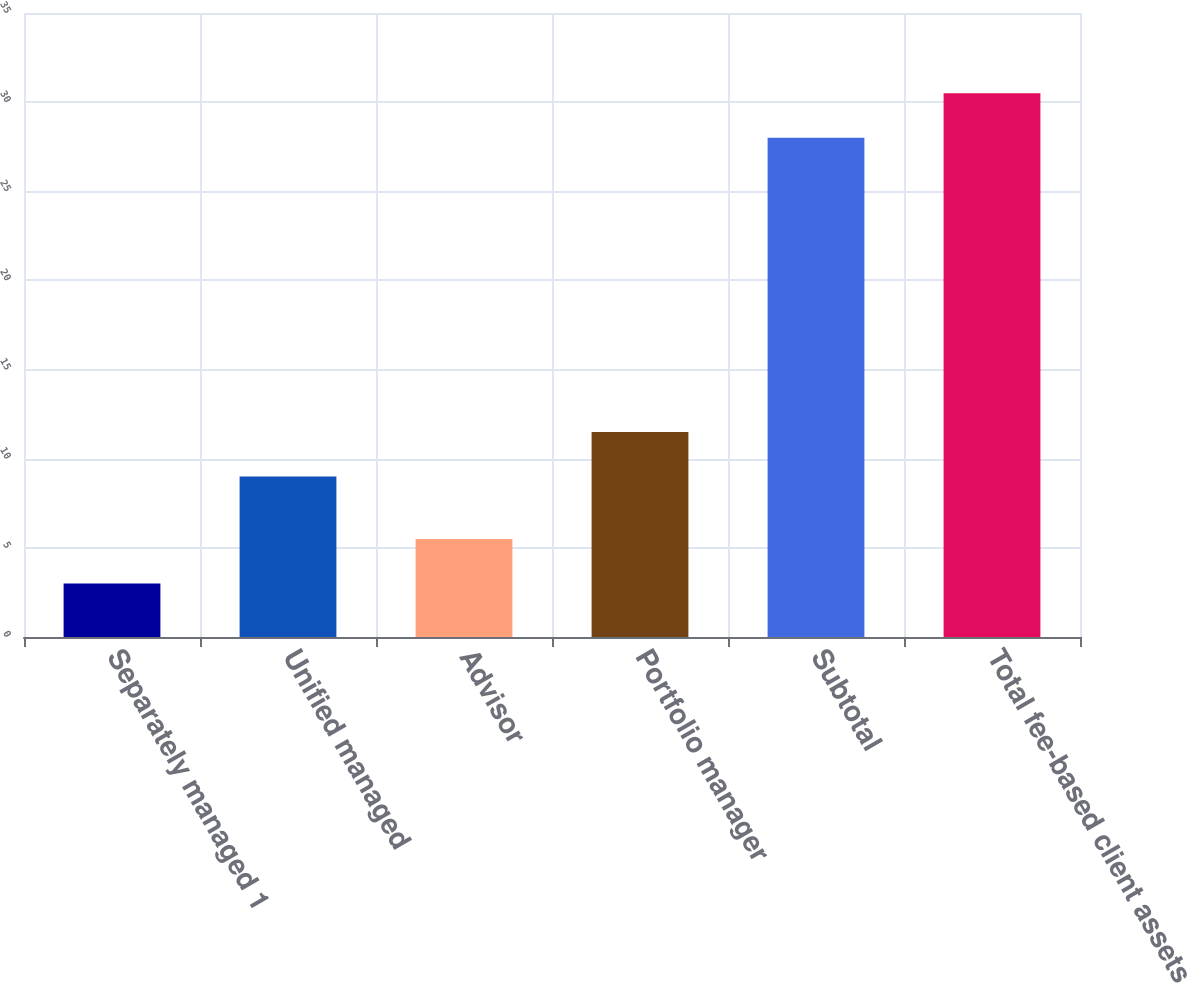Convert chart. <chart><loc_0><loc_0><loc_500><loc_500><bar_chart><fcel>Separately managed 1<fcel>Unified managed<fcel>Advisor<fcel>Portfolio manager<fcel>Subtotal<fcel>Total fee-based client assets<nl><fcel>3<fcel>9<fcel>5.5<fcel>11.5<fcel>28<fcel>30.5<nl></chart> 